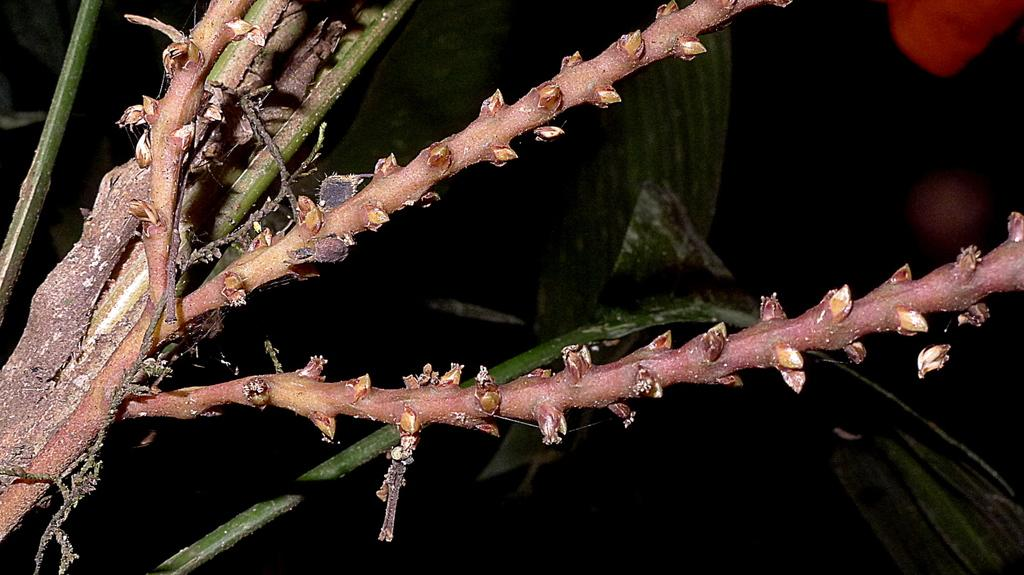What is the main subject of the image? The main subject of the image is a stem. Can you describe the stem in the image? Unfortunately, without more information, we cannot describe the stem in the image. How many snails can be seen crawling on the orange in the image? There is no orange or snails present in the image; it only features a stem. 